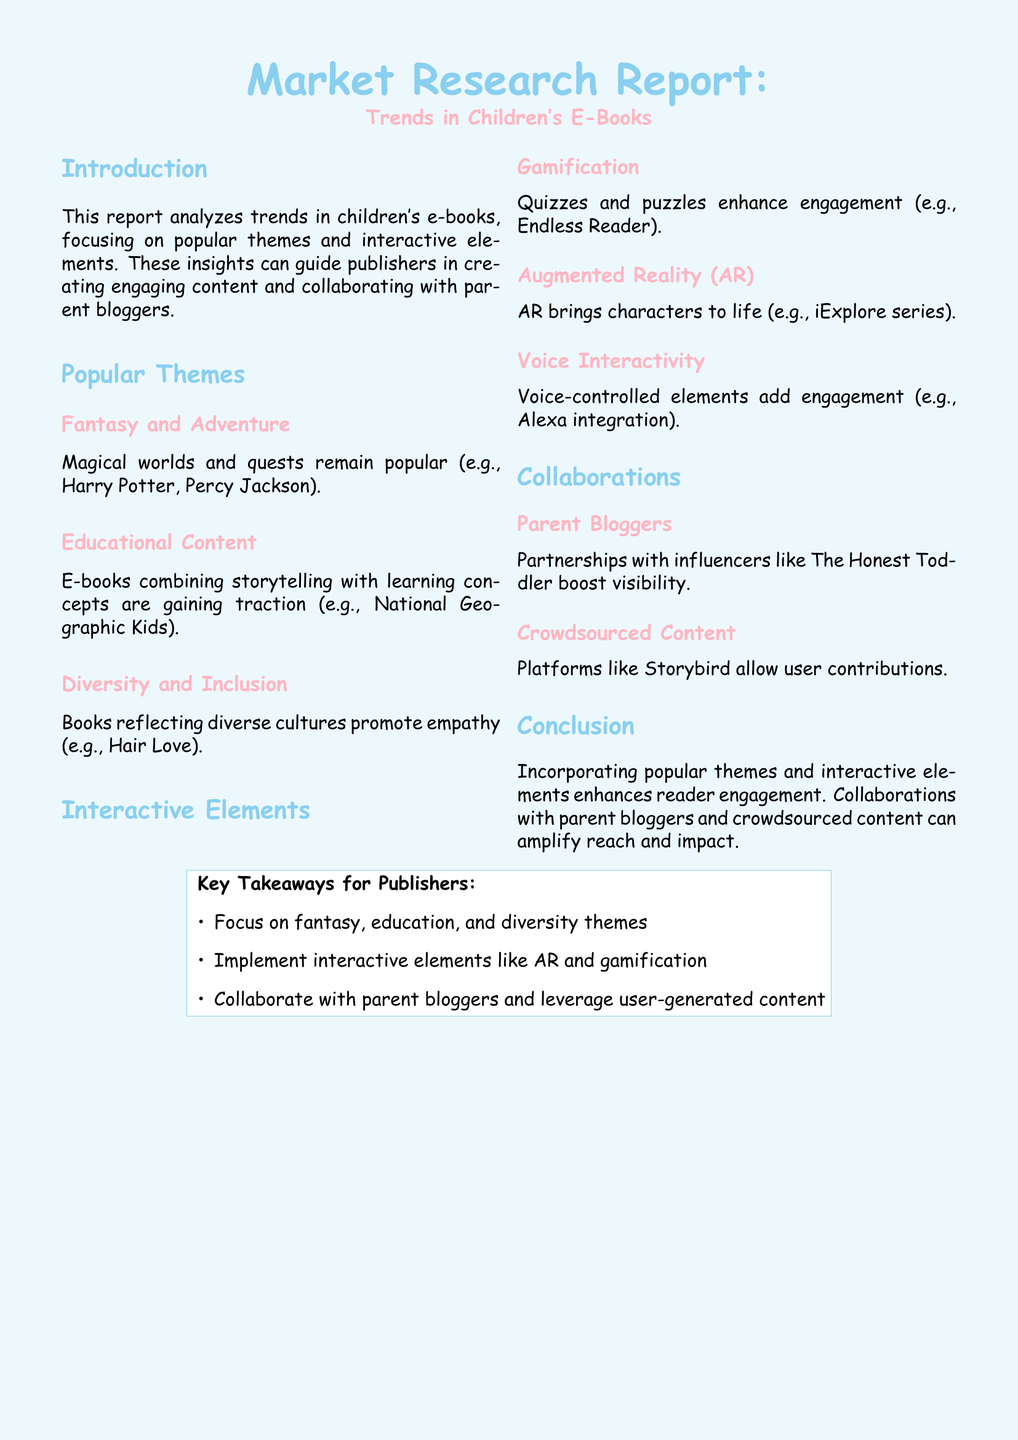What are the three popular themes in children's e-books? The document lists three themes: fantasy, educational content, and diversity and inclusion.
Answer: fantasy, educational content, diversity and inclusion What interactive element brings characters to life? Augmented Reality (AR) is mentioned as an interactive element that brings characters to life.
Answer: Augmented Reality (AR) Who is a parent blogger mentioned for collaboration? The Honest Toddler is specifically highlighted as an influencer for potential collaboration.
Answer: The Honest Toddler What type of content is popular for combining storytelling with learning? Educational content that blends storytelling with learning concepts is gaining traction as stated in the document.
Answer: Educational content What is the report's primary focus? The report focuses on analyzing trends in children's e-books related to themes and interactive elements.
Answer: trends in children's e-books What should publishers do to enhance reader engagement? Publishers should incorporate popular themes and interactive elements to enhance engagement.
Answer: incorporate popular themes and interactive elements Which interactive element is related to quizzes and puzzles? Gamification is the interactive element that involves quizzes and puzzles for enhancing engagement.
Answer: Gamification What is one method mentioned for reaching a larger audience? Collaborations with parent bloggers are suggested as a method for amplifying reach and impact.
Answer: Collaborations with parent bloggers 